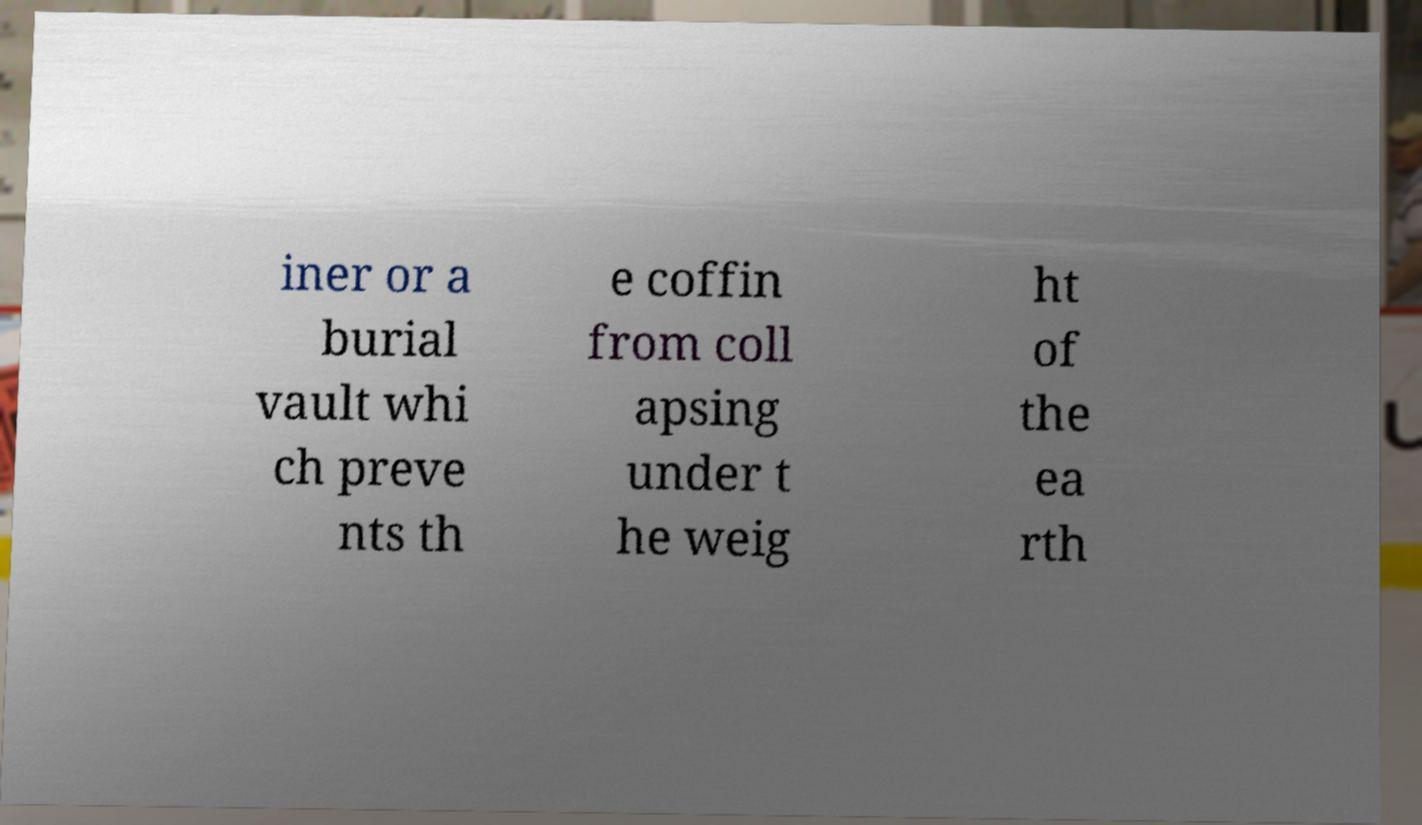There's text embedded in this image that I need extracted. Can you transcribe it verbatim? iner or a burial vault whi ch preve nts th e coffin from coll apsing under t he weig ht of the ea rth 